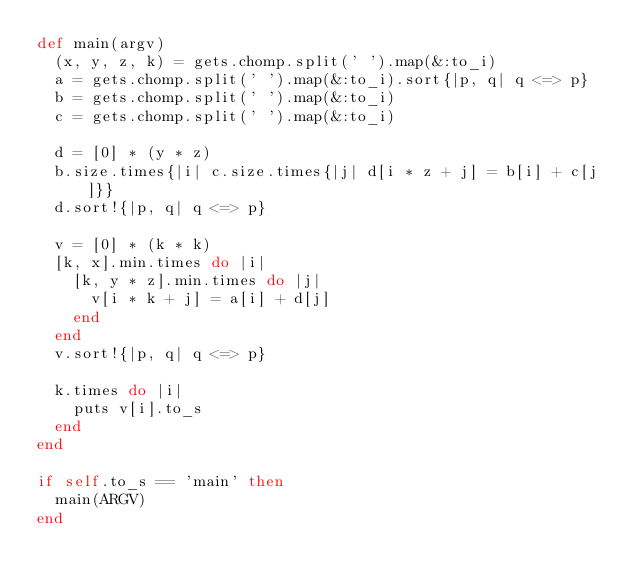<code> <loc_0><loc_0><loc_500><loc_500><_Ruby_>def main(argv)
  (x, y, z, k) = gets.chomp.split(' ').map(&:to_i)
  a = gets.chomp.split(' ').map(&:to_i).sort{|p, q| q <=> p}
  b = gets.chomp.split(' ').map(&:to_i)
  c = gets.chomp.split(' ').map(&:to_i)
  
  d = [0] * (y * z)
  b.size.times{|i| c.size.times{|j| d[i * z + j] = b[i] + c[j]}}
  d.sort!{|p, q| q <=> p}

  v = [0] * (k * k)
  [k, x].min.times do |i|
    [k, y * z].min.times do |j|
      v[i * k + j] = a[i] + d[j]
    end
  end
  v.sort!{|p, q| q <=> p}
  
  k.times do |i|
    puts v[i].to_s
  end
end

if self.to_s == 'main' then
  main(ARGV)
end</code> 